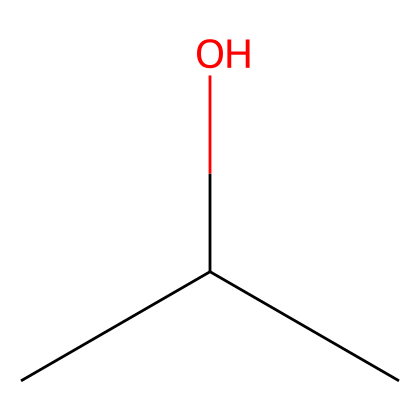What is the name of this chemical? The SMILES representation "CC(C)O" corresponds to isopropyl alcohol. The "CC(C)" indicates the carbon backbone structure, and the "O" indicates the presence of a hydroxyl group, which is characteristic of alcohols.
Answer: isopropyl alcohol How many carbon atoms are present in isopropyl alcohol? By examining the SMILES structure "CC(C)O," there are three "C"s present, indicating there are three carbon atoms.
Answer: three How many total hydrogen atoms are in isopropyl alcohol? To calculate the number of hydrogen atoms in isopropyl alcohol (C3H8O), we count three from the carbons (C3) and an additional one from the hydroxyl group (OH), resulting in 8 hydrogen atoms in total. Therefore, the formula C3H8 is derived from the general formula for alcohols.
Answer: eight What functional group is present in isopropyl alcohol? The hydroxyl group (-OH) indicated by the "O" in the SMILES representation "CC(C)O" identifies the alcohol functional group. This is the distinguishing feature of alcohols and responsible for their properties.
Answer: hydroxyl group Is isopropyl alcohol a polar or non-polar molecule? The presence of the hydroxyl group (-OH) introduces polarity due to the difference in electronegativity between oxygen and hydrogen, making isopropyl alcohol a polar molecule. The carbon skeleton remains hydrophobic, but the hydroxyl group outweighs that effect.
Answer: polar What type of liquid is isopropyl alcohol commonly used as in electronics cleaning? Isopropyl alcohol is classified as an organic solvent, specifically a cleaning solvent due to its ability to dissolve oils and remove dirt without leaving residue, making it valuable in electronics cleaning applications.
Answer: organic solvent 